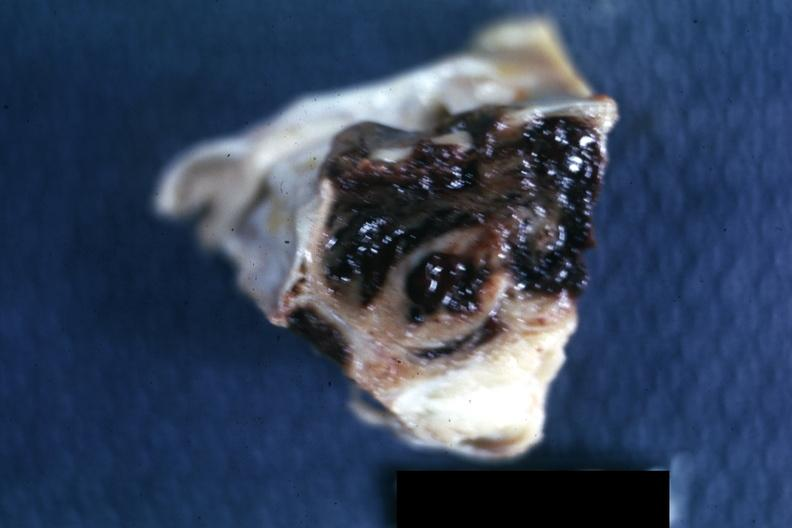s pituitary present?
Answer the question using a single word or phrase. Yes 